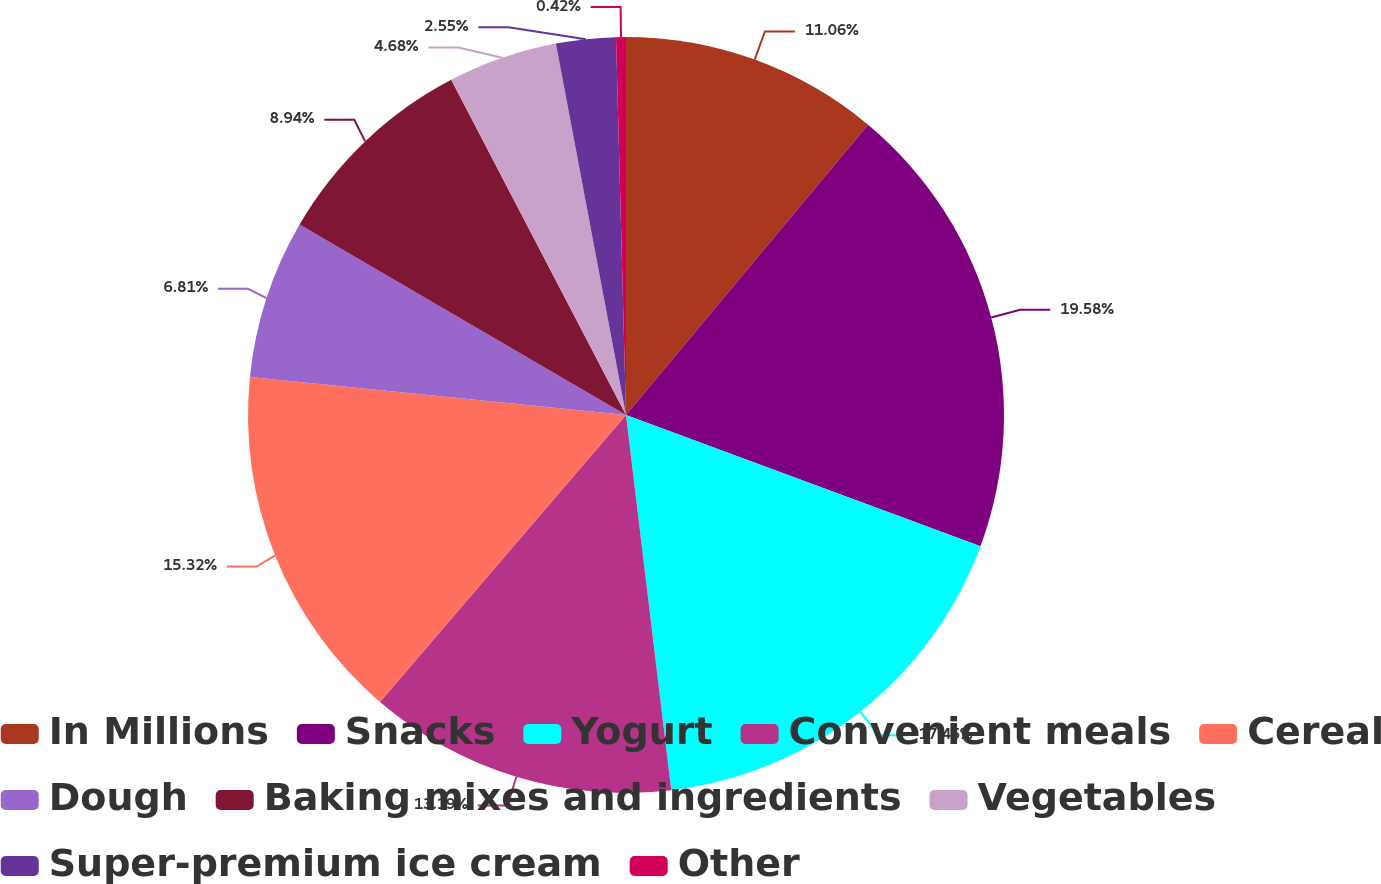Convert chart. <chart><loc_0><loc_0><loc_500><loc_500><pie_chart><fcel>In Millions<fcel>Snacks<fcel>Yogurt<fcel>Convenient meals<fcel>Cereal<fcel>Dough<fcel>Baking mixes and ingredients<fcel>Vegetables<fcel>Super-premium ice cream<fcel>Other<nl><fcel>11.06%<fcel>19.58%<fcel>17.45%<fcel>13.19%<fcel>15.32%<fcel>6.81%<fcel>8.94%<fcel>4.68%<fcel>2.55%<fcel>0.42%<nl></chart> 